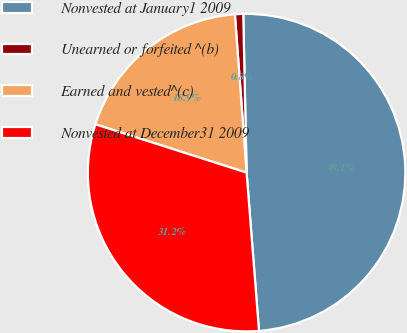Convert chart. <chart><loc_0><loc_0><loc_500><loc_500><pie_chart><fcel>Nonvested at January1 2009<fcel>Unearned or forfeited ^(b)<fcel>Earned and vested^(c)<fcel>Nonvested at December31 2009<nl><fcel>49.09%<fcel>0.84%<fcel>18.9%<fcel>31.17%<nl></chart> 